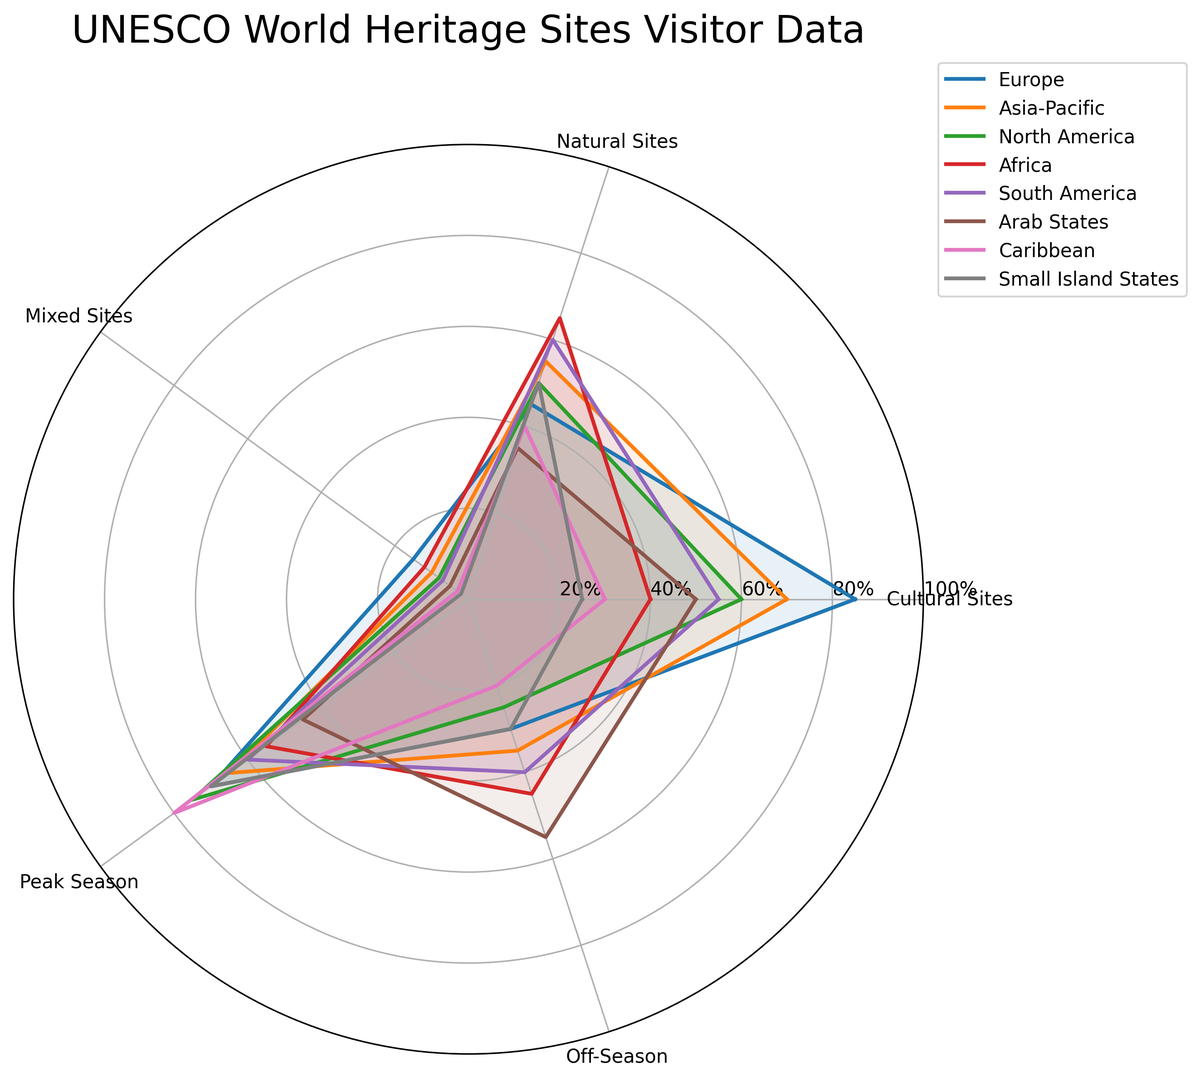What region has the highest number of visits to cultural sites? By looking at the radar chart, we see that Europe has the highest value at the Cultural Sites category.
Answer: Europe Which region has more visits to natural sites, Asia-Pacific or Africa? Referring to the values on the radar chart for Natural Sites, Africa has 65% while Asia-Pacific has 55%.
Answer: Africa Which region experiences more tourist visits during the peak season, Europe or Caribbean? The radar chart indicates that during the Peak Season category, the Caribbean has 80%, while Europe has 70%.
Answer: Caribbean What is the combined total percentage of visits to mixed sites for North America and South America? North America has 8% and South America has 7% in the Mixed Sites category. Adding these gives 8% + 7% = 15%.
Answer: 15% Which region has the lowest percentage of visits during off-season? By examining the Off-Season category on the radar chart, the Caribbean has the lowest value at 20%.
Answer: Caribbean Between Asia-Pacific and South America, which region has a higher overall average of visits across all sites? Calculate the average for Asia-Pacific: (70 + 55 + 10 + 65 + 35) / 5 = 47%. Calculate the average for South America: (55 + 60 + 7 + 60 + 40) / 5 = 44.4%. Asia-Pacific has a higher average.
Answer: Asia-Pacific In terms of visits to heritage sites, is the percentage difference more significant between Cultural Sites and Natural Sites for Europe or South America? For Europe, the difference between Cultural Sites (85%) and Natural Sites (45%) is 40%. For South America, the difference between Cultural Sites (55%) and Natural Sites (60%) is 5%. The difference is more significant for Europe.
Answer: Europe What are the values and trends observed for Mixed Sites in Small Island States? The radar chart shows that in Mixed Sites, Small Island States has a value of 2%, indicating a relatively low percentage of visits, showing that tourists likely visit other types of sites more.
Answer: 2% What's the median value of the Off-Season visits across all regions? Arranging the values for Off-Season visits - [20, 25, 30, 30, 35, 40, 45, 55] - the median is the average of the 4th and 5th values: (30 + 35) / 2 = 32.5.
Answer: 32.5 Between Africa and North America, which region shows a greater variation in visitor numbers across all types of sites and seasons? Calculating the range for Africa: [65, 55, 45, 40, 12] and for North America: [75, 60, 50, 50, 8], Africa varies from 12% to 65% making the range 53%, North America varies from 8% to 75%, making the range 67%. North America shows a greater variation.
Answer: North America 